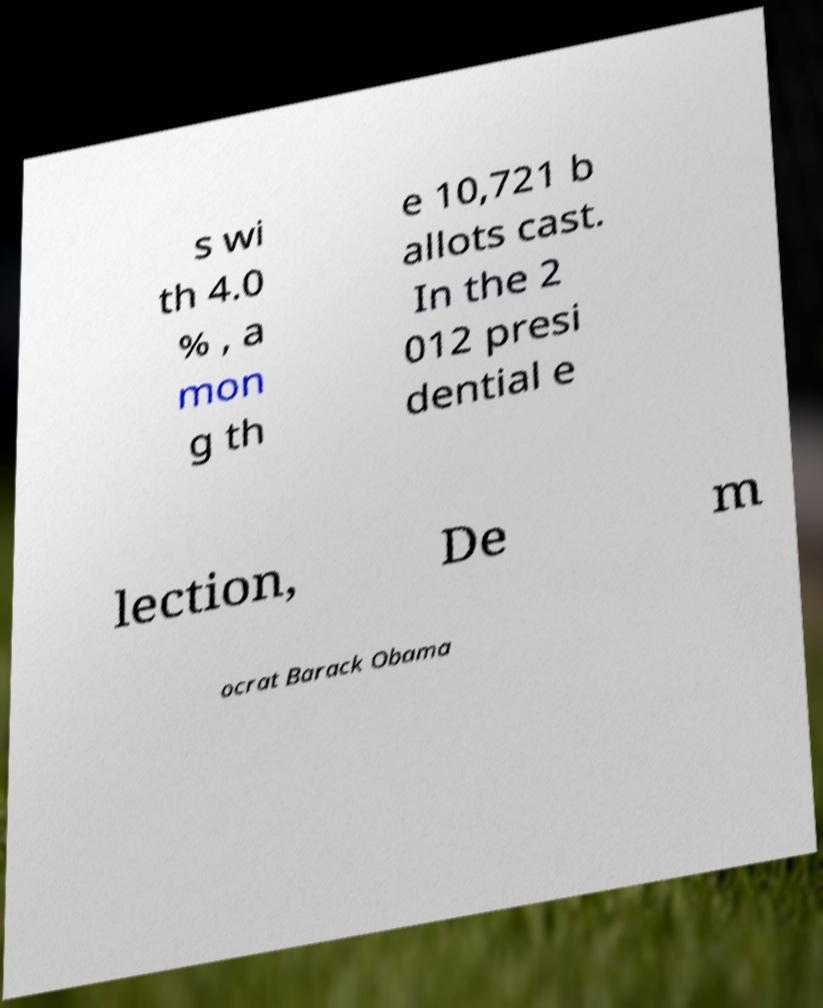What messages or text are displayed in this image? I need them in a readable, typed format. s wi th 4.0 % , a mon g th e 10,721 b allots cast. In the 2 012 presi dential e lection, De m ocrat Barack Obama 